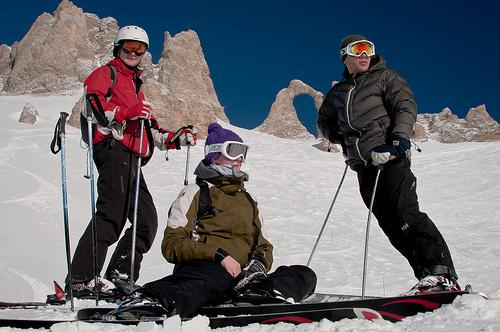Question: who is wearing goggles?
Choices:
A. Motorcycle rider.
B. Three skiers.
C. Snowboarder.
D. Swimmer.
Answer with the letter. Answer: B Question: what is red?
Choices:
A. One man's jacket.
B. The door.
C. The window.
D. Her hair.
Answer with the letter. Answer: A Question: where was the photo taken?
Choices:
A. Inside.
B. Outside.
C. At a ski slope.
D. An office.
Answer with the letter. Answer: C Question: why are people holding ski poles?
Choices:
A. To buy.
B. To use.
C. To ski.
D. For a photo.
Answer with the letter. Answer: C Question: when was the picture taken?
Choices:
A. Nighttime.
B. Noon.
C. Daytime.
D. This morning.
Answer with the letter. Answer: C Question: what is blue?
Choices:
A. Water.
B. Balls.
C. Flowers.
D. Sky.
Answer with the letter. Answer: D 